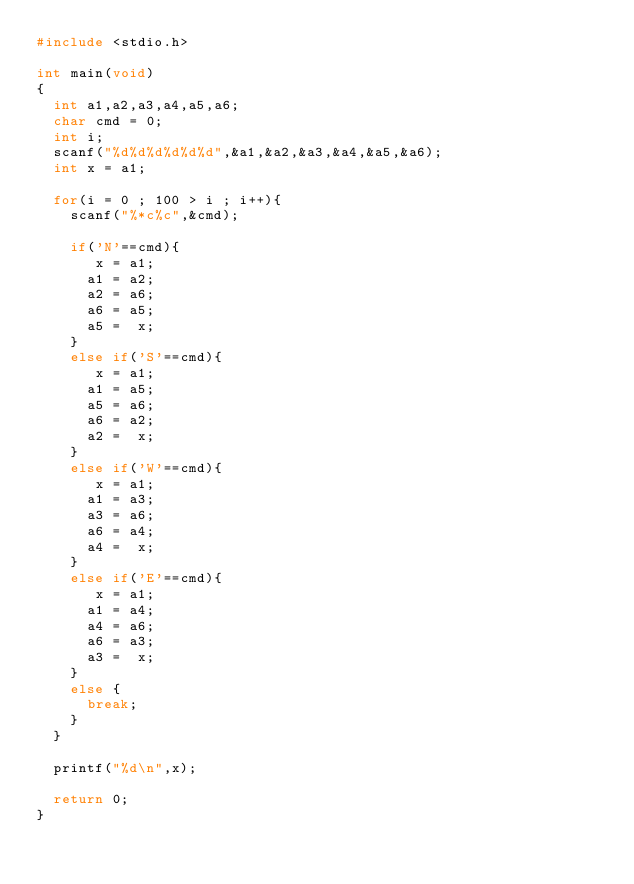Convert code to text. <code><loc_0><loc_0><loc_500><loc_500><_C_>#include <stdio.h>

int main(void)
{
	int a1,a2,a3,a4,a5,a6;
	char cmd = 0;
	int i;
	scanf("%d%d%d%d%d%d",&a1,&a2,&a3,&a4,&a5,&a6);
	int x = a1;
	
	for(i = 0 ; 100 > i ; i++){
		scanf("%*c%c",&cmd);
			
		if('N'==cmd){
			 x = a1;
			a1 = a2;
			a2 = a6;
			a6 = a5;
			a5 =  x;
		}
		else if('S'==cmd){
			 x = a1;
			a1 = a5;
			a5 = a6;
			a6 = a2;
			a2 =  x;
		}
		else if('W'==cmd){
			 x = a1;
			a1 = a3;
			a3 = a6;
			a6 = a4;
			a4 =  x;
		}
		else if('E'==cmd){
			 x = a1;
			a1 = a4;
			a4 = a6;
			a6 = a3;
			a3 =  x;
		}
		else {
			break;
		}
	}
	
	printf("%d\n",x);
	
	return 0;
}</code> 